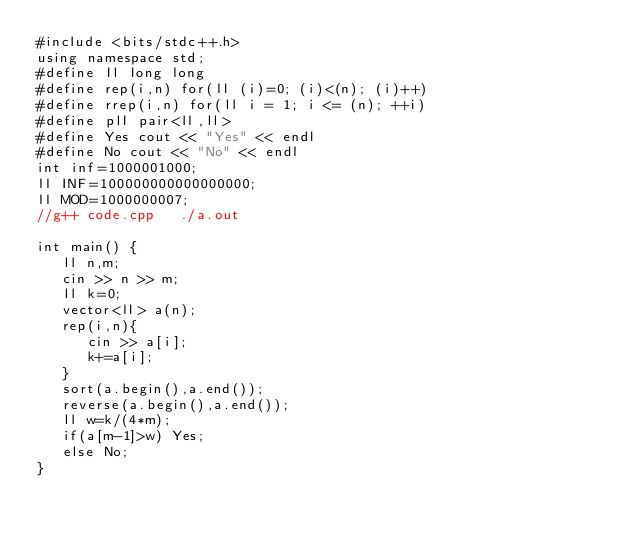Convert code to text. <code><loc_0><loc_0><loc_500><loc_500><_C++_>#include <bits/stdc++.h>
using namespace std;
#define ll long long
#define rep(i,n) for(ll (i)=0; (i)<(n); (i)++)
#define rrep(i,n) for(ll i = 1; i <= (n); ++i)
#define pll pair<ll,ll> 
#define Yes cout << "Yes" << endl
#define No cout << "No" << endl
int inf=1000001000;
ll INF=100000000000000000;
ll MOD=1000000007;
//g++ code.cpp   ./a.out 

int main() {
   ll n,m;
   cin >> n >> m;
   ll k=0;
   vector<ll> a(n);
   rep(i,n){
      cin >> a[i];
      k+=a[i];
   }
   sort(a.begin(),a.end());
   reverse(a.begin(),a.end());
   ll w=k/(4*m);
   if(a[m-1]>w) Yes;
   else No;
}

</code> 